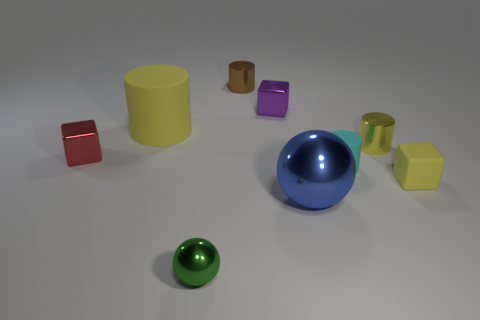The large thing that is in front of the large rubber cylinder has what shape?
Provide a short and direct response. Sphere. What is the color of the big shiny object?
Provide a short and direct response. Blue. Do the red shiny object and the shiny cube that is on the right side of the small green shiny object have the same size?
Provide a short and direct response. Yes. How many metallic objects are big purple cylinders or blocks?
Give a very brief answer. 2. There is a tiny matte block; is its color the same as the matte object left of the green metal sphere?
Make the answer very short. Yes. The tiny purple object has what shape?
Your response must be concise. Cube. There is a cylinder that is behind the large object that is to the left of the small metallic cylinder left of the cyan matte thing; how big is it?
Keep it short and to the point. Small. How many other things are the same shape as the cyan matte thing?
Provide a short and direct response. 3. There is a yellow rubber thing that is to the left of the blue shiny sphere; does it have the same shape as the tiny metallic thing that is right of the tiny purple block?
Make the answer very short. Yes. What number of blocks are either yellow things or brown things?
Provide a succinct answer. 1. 